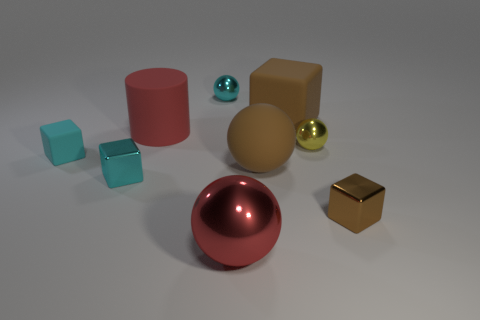What shape is the tiny thing that is the same color as the large rubber sphere?
Give a very brief answer. Cube. How many things are small yellow balls or small cyan objects?
Provide a succinct answer. 4. There is a big red thing that is behind the tiny block that is to the right of the large matte ball; what shape is it?
Ensure brevity in your answer.  Cylinder. There is a small shiny thing that is on the right side of the tiny yellow shiny object; does it have the same shape as the big red metallic thing?
Provide a short and direct response. No. What is the size of the other cube that is the same material as the large block?
Offer a very short reply. Small. What number of objects are things that are to the left of the small brown shiny object or matte objects that are behind the rubber cylinder?
Offer a very short reply. 8. Are there an equal number of big red matte cylinders that are to the right of the small yellow metal object and tiny yellow objects right of the big block?
Ensure brevity in your answer.  No. What color is the shiny cube on the right side of the big matte block?
Make the answer very short. Brown. Does the big rubber cylinder have the same color as the metal ball that is in front of the cyan metallic cube?
Your answer should be compact. Yes. Are there fewer cyan metal spheres than small cyan blocks?
Give a very brief answer. Yes. 